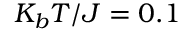Convert formula to latex. <formula><loc_0><loc_0><loc_500><loc_500>K _ { b } T / J = 0 . 1</formula> 